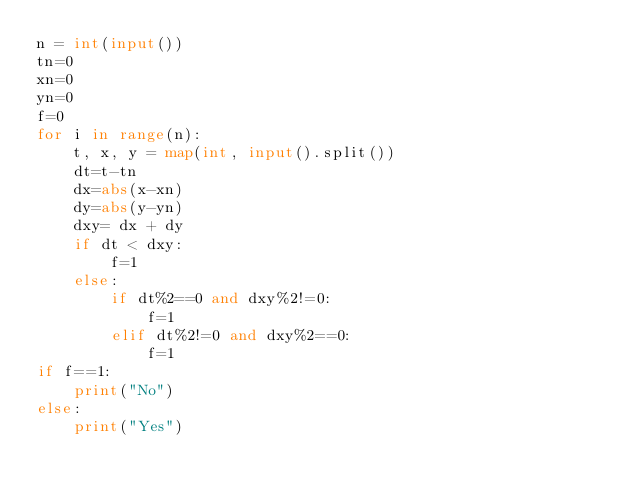Convert code to text. <code><loc_0><loc_0><loc_500><loc_500><_Python_>n = int(input())
tn=0
xn=0
yn=0
f=0
for i in range(n):
    t, x, y = map(int, input().split())
    dt=t-tn
    dx=abs(x-xn)
    dy=abs(y-yn)
    dxy= dx + dy
    if dt < dxy:
        f=1
    else:
        if dt%2==0 and dxy%2!=0:
            f=1
        elif dt%2!=0 and dxy%2==0:
            f=1
if f==1:
    print("No")
else:
    print("Yes")
</code> 